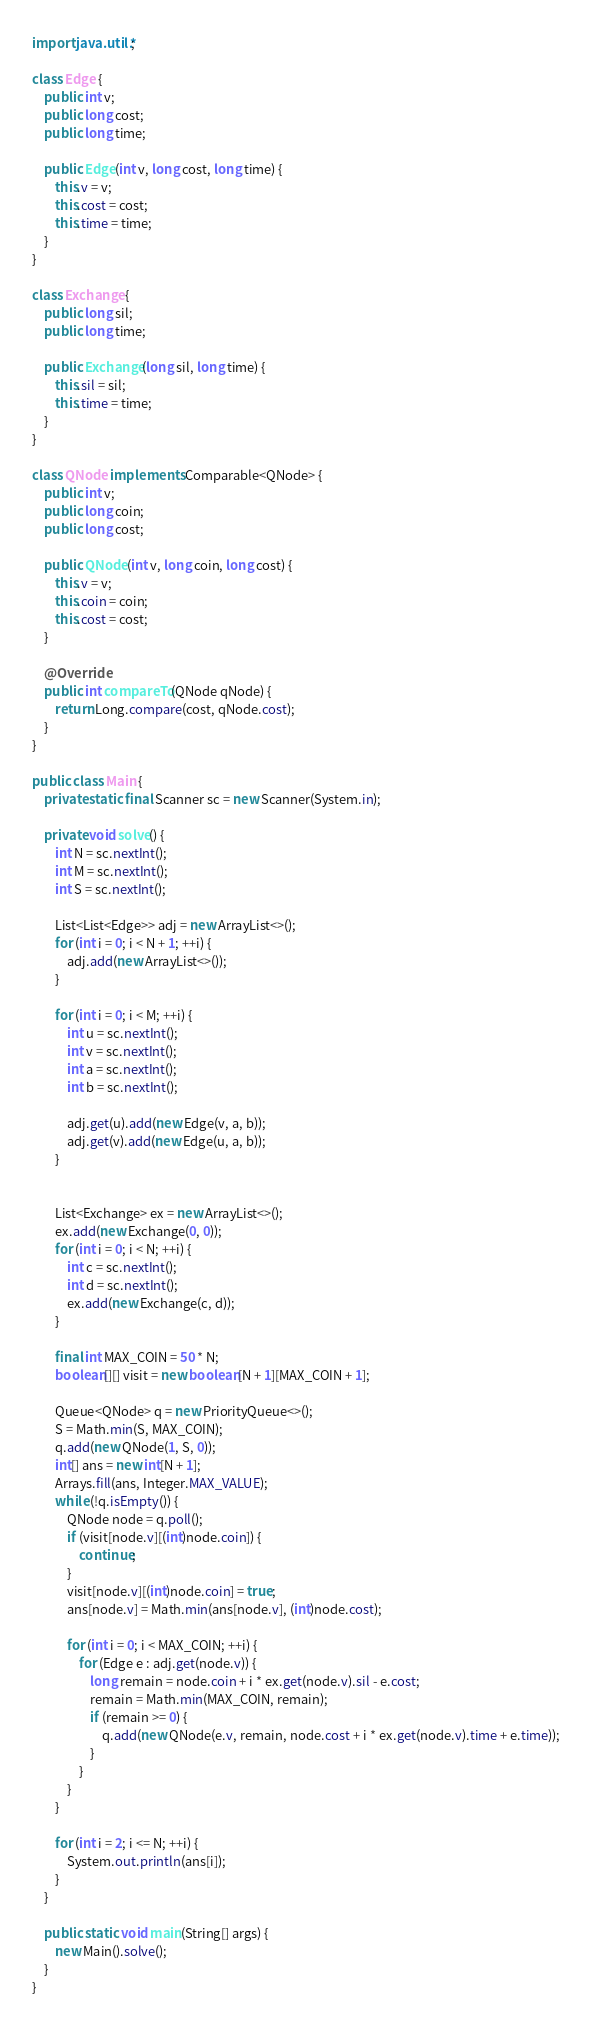<code> <loc_0><loc_0><loc_500><loc_500><_Java_>
import java.util.*;

class Edge {
    public int v;
    public long cost;
    public long time;

    public Edge(int v, long cost, long time) {
        this.v = v;
        this.cost = cost;
        this.time = time;
    }
}

class Exchange {
    public long sil;
    public long time;

    public Exchange(long sil, long time) {
        this.sil = sil;
        this.time = time;
    }
}

class QNode implements Comparable<QNode> {
    public int v;
    public long coin;
    public long cost;

    public QNode(int v, long coin, long cost) {
        this.v = v;
        this.coin = coin;
        this.cost = cost;
    }

    @Override
    public int compareTo(QNode qNode) {
        return Long.compare(cost, qNode.cost);
    }
}

public class Main {
    private static final Scanner sc = new Scanner(System.in);

    private void solve() {
        int N = sc.nextInt();
        int M = sc.nextInt();
        int S = sc.nextInt();

        List<List<Edge>> adj = new ArrayList<>();
        for (int i = 0; i < N + 1; ++i) {
            adj.add(new ArrayList<>());
        }

        for (int i = 0; i < M; ++i) {
            int u = sc.nextInt();
            int v = sc.nextInt();
            int a = sc.nextInt();
            int b = sc.nextInt();

            adj.get(u).add(new Edge(v, a, b));
            adj.get(v).add(new Edge(u, a, b));
        }


        List<Exchange> ex = new ArrayList<>();
        ex.add(new Exchange(0, 0));
        for (int i = 0; i < N; ++i) {
            int c = sc.nextInt();
            int d = sc.nextInt();
            ex.add(new Exchange(c, d));
        }

        final int MAX_COIN = 50 * N;
        boolean[][] visit = new boolean[N + 1][MAX_COIN + 1];

        Queue<QNode> q = new PriorityQueue<>();
        S = Math.min(S, MAX_COIN);
        q.add(new QNode(1, S, 0));
        int[] ans = new int[N + 1];
        Arrays.fill(ans, Integer.MAX_VALUE);
        while (!q.isEmpty()) {
            QNode node = q.poll();
            if (visit[node.v][(int)node.coin]) {
                continue;
            }
            visit[node.v][(int)node.coin] = true;
            ans[node.v] = Math.min(ans[node.v], (int)node.cost);

            for (int i = 0; i < MAX_COIN; ++i) {
                for (Edge e : adj.get(node.v)) {
                    long remain = node.coin + i * ex.get(node.v).sil - e.cost;
                    remain = Math.min(MAX_COIN, remain);
                    if (remain >= 0) {
                        q.add(new QNode(e.v, remain, node.cost + i * ex.get(node.v).time + e.time));
                    }
                }
            }
        }

        for (int i = 2; i <= N; ++i) {
            System.out.println(ans[i]);
        }
    }

    public static void main(String[] args) {
        new Main().solve();
    }
}</code> 